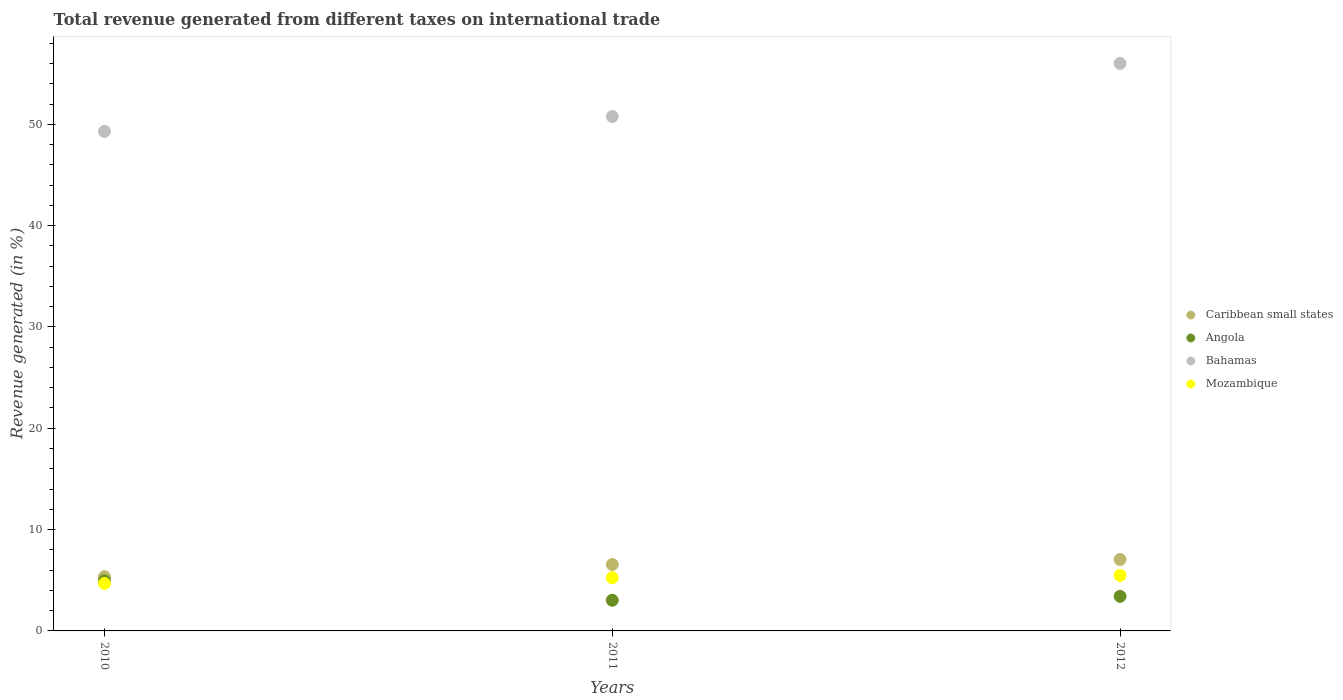Is the number of dotlines equal to the number of legend labels?
Provide a succinct answer. Yes. What is the total revenue generated in Caribbean small states in 2011?
Offer a very short reply. 6.55. Across all years, what is the maximum total revenue generated in Bahamas?
Offer a very short reply. 56.01. Across all years, what is the minimum total revenue generated in Bahamas?
Provide a short and direct response. 49.29. In which year was the total revenue generated in Angola minimum?
Offer a terse response. 2011. What is the total total revenue generated in Bahamas in the graph?
Your answer should be very brief. 156.06. What is the difference between the total revenue generated in Caribbean small states in 2010 and that in 2011?
Provide a short and direct response. -1.2. What is the difference between the total revenue generated in Mozambique in 2011 and the total revenue generated in Bahamas in 2010?
Offer a very short reply. -44.04. What is the average total revenue generated in Caribbean small states per year?
Keep it short and to the point. 6.32. In the year 2010, what is the difference between the total revenue generated in Caribbean small states and total revenue generated in Angola?
Ensure brevity in your answer.  0.4. What is the ratio of the total revenue generated in Caribbean small states in 2010 to that in 2012?
Ensure brevity in your answer.  0.76. Is the total revenue generated in Mozambique in 2010 less than that in 2012?
Provide a succinct answer. Yes. Is the difference between the total revenue generated in Caribbean small states in 2011 and 2012 greater than the difference between the total revenue generated in Angola in 2011 and 2012?
Give a very brief answer. No. What is the difference between the highest and the second highest total revenue generated in Angola?
Provide a succinct answer. 1.54. What is the difference between the highest and the lowest total revenue generated in Bahamas?
Your response must be concise. 6.71. In how many years, is the total revenue generated in Angola greater than the average total revenue generated in Angola taken over all years?
Keep it short and to the point. 1. Is the sum of the total revenue generated in Bahamas in 2010 and 2011 greater than the maximum total revenue generated in Mozambique across all years?
Make the answer very short. Yes. Is the total revenue generated in Bahamas strictly greater than the total revenue generated in Mozambique over the years?
Keep it short and to the point. Yes. How many years are there in the graph?
Offer a terse response. 3. Are the values on the major ticks of Y-axis written in scientific E-notation?
Provide a succinct answer. No. Does the graph contain grids?
Provide a succinct answer. No. How many legend labels are there?
Offer a very short reply. 4. What is the title of the graph?
Your answer should be compact. Total revenue generated from different taxes on international trade. What is the label or title of the Y-axis?
Give a very brief answer. Revenue generated (in %). What is the Revenue generated (in %) in Caribbean small states in 2010?
Your response must be concise. 5.35. What is the Revenue generated (in %) of Angola in 2010?
Make the answer very short. 4.95. What is the Revenue generated (in %) in Bahamas in 2010?
Provide a short and direct response. 49.29. What is the Revenue generated (in %) in Mozambique in 2010?
Offer a very short reply. 4.68. What is the Revenue generated (in %) in Caribbean small states in 2011?
Give a very brief answer. 6.55. What is the Revenue generated (in %) of Angola in 2011?
Your answer should be compact. 3.03. What is the Revenue generated (in %) in Bahamas in 2011?
Your answer should be very brief. 50.76. What is the Revenue generated (in %) of Mozambique in 2011?
Give a very brief answer. 5.25. What is the Revenue generated (in %) of Caribbean small states in 2012?
Your answer should be compact. 7.05. What is the Revenue generated (in %) of Angola in 2012?
Offer a very short reply. 3.41. What is the Revenue generated (in %) in Bahamas in 2012?
Offer a very short reply. 56.01. What is the Revenue generated (in %) of Mozambique in 2012?
Make the answer very short. 5.48. Across all years, what is the maximum Revenue generated (in %) of Caribbean small states?
Give a very brief answer. 7.05. Across all years, what is the maximum Revenue generated (in %) in Angola?
Offer a terse response. 4.95. Across all years, what is the maximum Revenue generated (in %) in Bahamas?
Provide a short and direct response. 56.01. Across all years, what is the maximum Revenue generated (in %) of Mozambique?
Offer a terse response. 5.48. Across all years, what is the minimum Revenue generated (in %) in Caribbean small states?
Offer a terse response. 5.35. Across all years, what is the minimum Revenue generated (in %) in Angola?
Your answer should be compact. 3.03. Across all years, what is the minimum Revenue generated (in %) in Bahamas?
Give a very brief answer. 49.29. Across all years, what is the minimum Revenue generated (in %) of Mozambique?
Give a very brief answer. 4.68. What is the total Revenue generated (in %) in Caribbean small states in the graph?
Your response must be concise. 18.95. What is the total Revenue generated (in %) of Angola in the graph?
Your answer should be compact. 11.39. What is the total Revenue generated (in %) of Bahamas in the graph?
Your answer should be very brief. 156.06. What is the total Revenue generated (in %) in Mozambique in the graph?
Your answer should be compact. 15.41. What is the difference between the Revenue generated (in %) in Caribbean small states in 2010 and that in 2011?
Offer a very short reply. -1.2. What is the difference between the Revenue generated (in %) in Angola in 2010 and that in 2011?
Give a very brief answer. 1.93. What is the difference between the Revenue generated (in %) in Bahamas in 2010 and that in 2011?
Give a very brief answer. -1.47. What is the difference between the Revenue generated (in %) in Mozambique in 2010 and that in 2011?
Keep it short and to the point. -0.57. What is the difference between the Revenue generated (in %) of Caribbean small states in 2010 and that in 2012?
Offer a terse response. -1.7. What is the difference between the Revenue generated (in %) in Angola in 2010 and that in 2012?
Offer a terse response. 1.54. What is the difference between the Revenue generated (in %) in Bahamas in 2010 and that in 2012?
Offer a very short reply. -6.71. What is the difference between the Revenue generated (in %) of Mozambique in 2010 and that in 2012?
Your response must be concise. -0.79. What is the difference between the Revenue generated (in %) in Caribbean small states in 2011 and that in 2012?
Offer a very short reply. -0.5. What is the difference between the Revenue generated (in %) in Angola in 2011 and that in 2012?
Your answer should be compact. -0.39. What is the difference between the Revenue generated (in %) of Bahamas in 2011 and that in 2012?
Give a very brief answer. -5.24. What is the difference between the Revenue generated (in %) in Mozambique in 2011 and that in 2012?
Provide a succinct answer. -0.23. What is the difference between the Revenue generated (in %) in Caribbean small states in 2010 and the Revenue generated (in %) in Angola in 2011?
Give a very brief answer. 2.32. What is the difference between the Revenue generated (in %) in Caribbean small states in 2010 and the Revenue generated (in %) in Bahamas in 2011?
Your answer should be compact. -45.41. What is the difference between the Revenue generated (in %) in Caribbean small states in 2010 and the Revenue generated (in %) in Mozambique in 2011?
Your answer should be compact. 0.1. What is the difference between the Revenue generated (in %) of Angola in 2010 and the Revenue generated (in %) of Bahamas in 2011?
Ensure brevity in your answer.  -45.81. What is the difference between the Revenue generated (in %) in Angola in 2010 and the Revenue generated (in %) in Mozambique in 2011?
Offer a very short reply. -0.3. What is the difference between the Revenue generated (in %) in Bahamas in 2010 and the Revenue generated (in %) in Mozambique in 2011?
Ensure brevity in your answer.  44.04. What is the difference between the Revenue generated (in %) of Caribbean small states in 2010 and the Revenue generated (in %) of Angola in 2012?
Ensure brevity in your answer.  1.94. What is the difference between the Revenue generated (in %) of Caribbean small states in 2010 and the Revenue generated (in %) of Bahamas in 2012?
Your response must be concise. -50.66. What is the difference between the Revenue generated (in %) in Caribbean small states in 2010 and the Revenue generated (in %) in Mozambique in 2012?
Offer a terse response. -0.13. What is the difference between the Revenue generated (in %) in Angola in 2010 and the Revenue generated (in %) in Bahamas in 2012?
Your response must be concise. -51.05. What is the difference between the Revenue generated (in %) in Angola in 2010 and the Revenue generated (in %) in Mozambique in 2012?
Your answer should be very brief. -0.52. What is the difference between the Revenue generated (in %) of Bahamas in 2010 and the Revenue generated (in %) of Mozambique in 2012?
Your answer should be compact. 43.82. What is the difference between the Revenue generated (in %) in Caribbean small states in 2011 and the Revenue generated (in %) in Angola in 2012?
Ensure brevity in your answer.  3.14. What is the difference between the Revenue generated (in %) in Caribbean small states in 2011 and the Revenue generated (in %) in Bahamas in 2012?
Provide a short and direct response. -49.45. What is the difference between the Revenue generated (in %) of Caribbean small states in 2011 and the Revenue generated (in %) of Mozambique in 2012?
Your answer should be very brief. 1.08. What is the difference between the Revenue generated (in %) of Angola in 2011 and the Revenue generated (in %) of Bahamas in 2012?
Offer a terse response. -52.98. What is the difference between the Revenue generated (in %) in Angola in 2011 and the Revenue generated (in %) in Mozambique in 2012?
Offer a very short reply. -2.45. What is the difference between the Revenue generated (in %) of Bahamas in 2011 and the Revenue generated (in %) of Mozambique in 2012?
Offer a terse response. 45.29. What is the average Revenue generated (in %) in Caribbean small states per year?
Your answer should be very brief. 6.32. What is the average Revenue generated (in %) in Angola per year?
Your response must be concise. 3.8. What is the average Revenue generated (in %) of Bahamas per year?
Your response must be concise. 52.02. What is the average Revenue generated (in %) in Mozambique per year?
Offer a very short reply. 5.14. In the year 2010, what is the difference between the Revenue generated (in %) of Caribbean small states and Revenue generated (in %) of Angola?
Offer a very short reply. 0.4. In the year 2010, what is the difference between the Revenue generated (in %) in Caribbean small states and Revenue generated (in %) in Bahamas?
Keep it short and to the point. -43.94. In the year 2010, what is the difference between the Revenue generated (in %) of Caribbean small states and Revenue generated (in %) of Mozambique?
Ensure brevity in your answer.  0.67. In the year 2010, what is the difference between the Revenue generated (in %) in Angola and Revenue generated (in %) in Bahamas?
Offer a very short reply. -44.34. In the year 2010, what is the difference between the Revenue generated (in %) of Angola and Revenue generated (in %) of Mozambique?
Keep it short and to the point. 0.27. In the year 2010, what is the difference between the Revenue generated (in %) in Bahamas and Revenue generated (in %) in Mozambique?
Offer a terse response. 44.61. In the year 2011, what is the difference between the Revenue generated (in %) in Caribbean small states and Revenue generated (in %) in Angola?
Provide a short and direct response. 3.53. In the year 2011, what is the difference between the Revenue generated (in %) in Caribbean small states and Revenue generated (in %) in Bahamas?
Your response must be concise. -44.21. In the year 2011, what is the difference between the Revenue generated (in %) of Caribbean small states and Revenue generated (in %) of Mozambique?
Offer a very short reply. 1.3. In the year 2011, what is the difference between the Revenue generated (in %) of Angola and Revenue generated (in %) of Bahamas?
Your response must be concise. -47.74. In the year 2011, what is the difference between the Revenue generated (in %) of Angola and Revenue generated (in %) of Mozambique?
Keep it short and to the point. -2.22. In the year 2011, what is the difference between the Revenue generated (in %) in Bahamas and Revenue generated (in %) in Mozambique?
Provide a succinct answer. 45.51. In the year 2012, what is the difference between the Revenue generated (in %) in Caribbean small states and Revenue generated (in %) in Angola?
Offer a very short reply. 3.64. In the year 2012, what is the difference between the Revenue generated (in %) of Caribbean small states and Revenue generated (in %) of Bahamas?
Offer a very short reply. -48.96. In the year 2012, what is the difference between the Revenue generated (in %) in Caribbean small states and Revenue generated (in %) in Mozambique?
Offer a very short reply. 1.57. In the year 2012, what is the difference between the Revenue generated (in %) of Angola and Revenue generated (in %) of Bahamas?
Provide a succinct answer. -52.59. In the year 2012, what is the difference between the Revenue generated (in %) in Angola and Revenue generated (in %) in Mozambique?
Make the answer very short. -2.06. In the year 2012, what is the difference between the Revenue generated (in %) in Bahamas and Revenue generated (in %) in Mozambique?
Keep it short and to the point. 50.53. What is the ratio of the Revenue generated (in %) in Caribbean small states in 2010 to that in 2011?
Your response must be concise. 0.82. What is the ratio of the Revenue generated (in %) in Angola in 2010 to that in 2011?
Your response must be concise. 1.64. What is the ratio of the Revenue generated (in %) in Bahamas in 2010 to that in 2011?
Offer a very short reply. 0.97. What is the ratio of the Revenue generated (in %) in Mozambique in 2010 to that in 2011?
Make the answer very short. 0.89. What is the ratio of the Revenue generated (in %) of Caribbean small states in 2010 to that in 2012?
Provide a succinct answer. 0.76. What is the ratio of the Revenue generated (in %) of Angola in 2010 to that in 2012?
Your response must be concise. 1.45. What is the ratio of the Revenue generated (in %) in Bahamas in 2010 to that in 2012?
Make the answer very short. 0.88. What is the ratio of the Revenue generated (in %) of Mozambique in 2010 to that in 2012?
Provide a succinct answer. 0.86. What is the ratio of the Revenue generated (in %) of Caribbean small states in 2011 to that in 2012?
Offer a very short reply. 0.93. What is the ratio of the Revenue generated (in %) in Angola in 2011 to that in 2012?
Provide a succinct answer. 0.89. What is the ratio of the Revenue generated (in %) of Bahamas in 2011 to that in 2012?
Offer a terse response. 0.91. What is the ratio of the Revenue generated (in %) in Mozambique in 2011 to that in 2012?
Make the answer very short. 0.96. What is the difference between the highest and the second highest Revenue generated (in %) of Caribbean small states?
Your answer should be compact. 0.5. What is the difference between the highest and the second highest Revenue generated (in %) of Angola?
Keep it short and to the point. 1.54. What is the difference between the highest and the second highest Revenue generated (in %) of Bahamas?
Ensure brevity in your answer.  5.24. What is the difference between the highest and the second highest Revenue generated (in %) in Mozambique?
Your response must be concise. 0.23. What is the difference between the highest and the lowest Revenue generated (in %) of Caribbean small states?
Make the answer very short. 1.7. What is the difference between the highest and the lowest Revenue generated (in %) in Angola?
Provide a succinct answer. 1.93. What is the difference between the highest and the lowest Revenue generated (in %) in Bahamas?
Your response must be concise. 6.71. What is the difference between the highest and the lowest Revenue generated (in %) of Mozambique?
Keep it short and to the point. 0.79. 